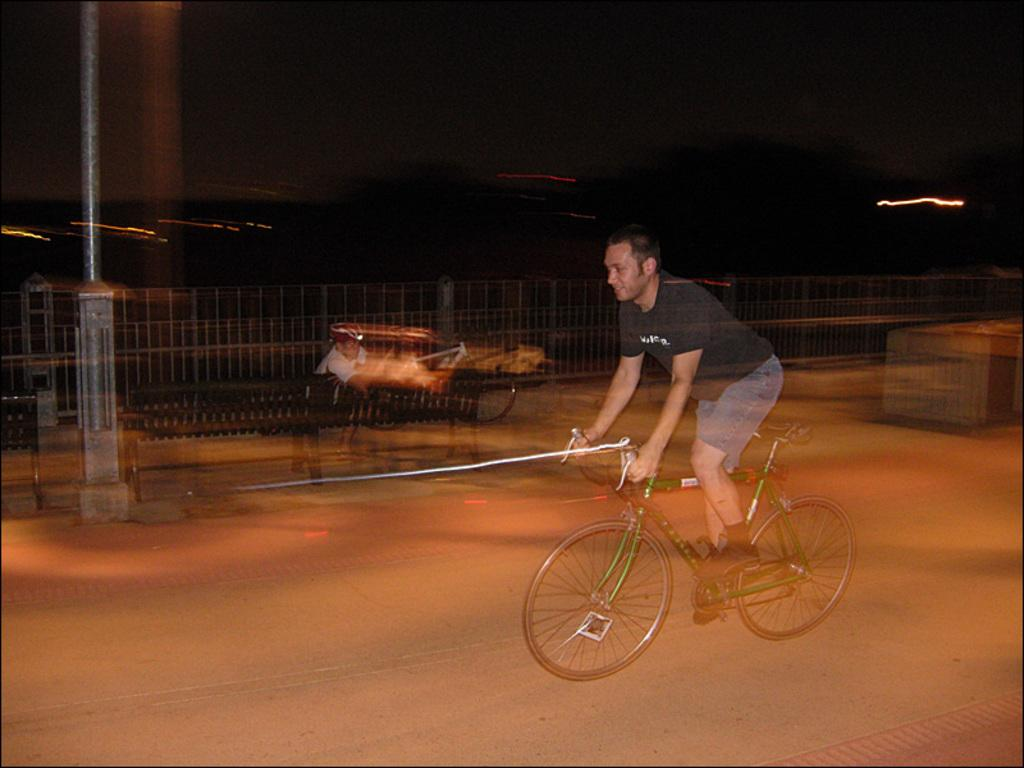What is the man in the image doing? There is a man riding a bicycle in the image. Where is the man riding the bicycle? The man is on the road. Are there any other people in the image? Yes, there is another man seated on a bench in the image. What type of wrench is the man using while riding the bicycle in the image? There is no wrench present in the image; the man is simply riding a bicycle. 